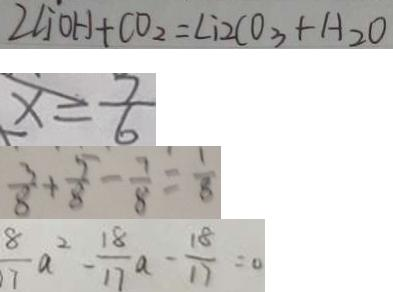Convert formula to latex. <formula><loc_0><loc_0><loc_500><loc_500>2 \angle j ^ { . } O H + C O _ { 2 } = \angle i 2 C O _ { 3 } + H _ { 2 } O 
 x = \frac { 7 } { 6 } 
 \frac { 3 } { 8 } + \frac { 5 } { 8 } - \frac { 7 } { 8 } = \frac { 1 } { 8 } 
 \frac { 8 } { 7 } a ^ { 2 } - \frac { 1 8 } { 1 7 } a - \frac { 1 8 } { 1 7 } = 0</formula> 